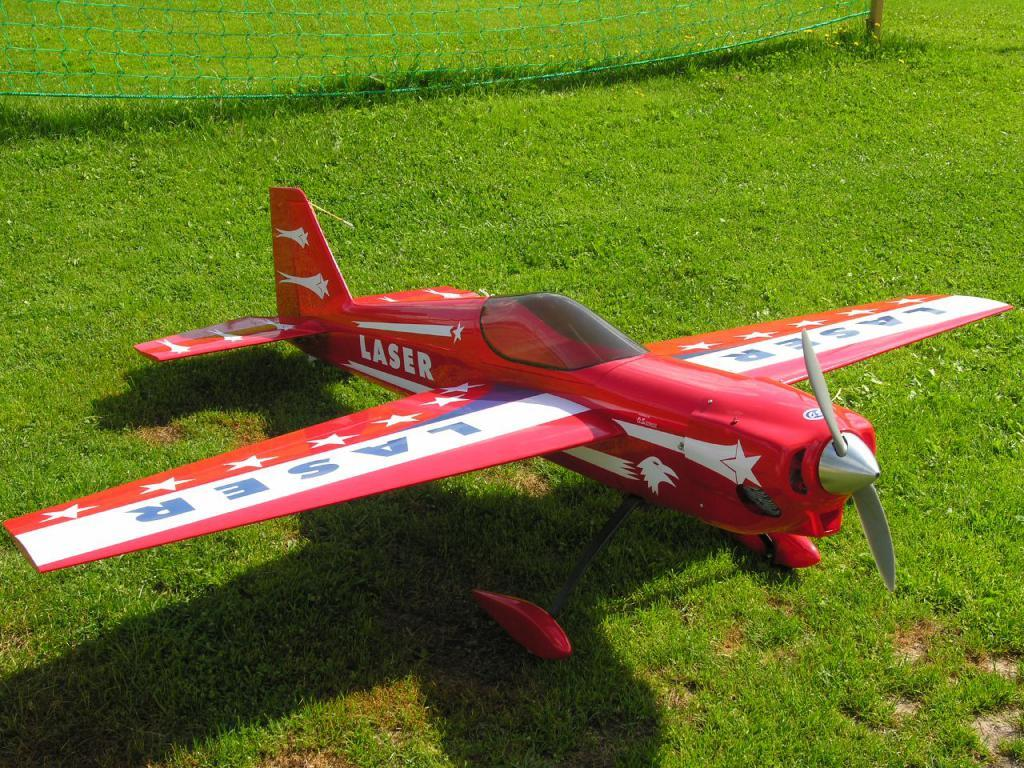What is the main subject of the image? The main subject of the image is a toy airplane. Where is the toy airplane located in the image? The toy airplane is in the middle of the image. What type of environment is visible in the background of the image? There is grass visible in the background of the image. What type of yam is being used to support the toy airplane in the image? There is no yam present in the image, and the toy airplane is not being supported by any object. 